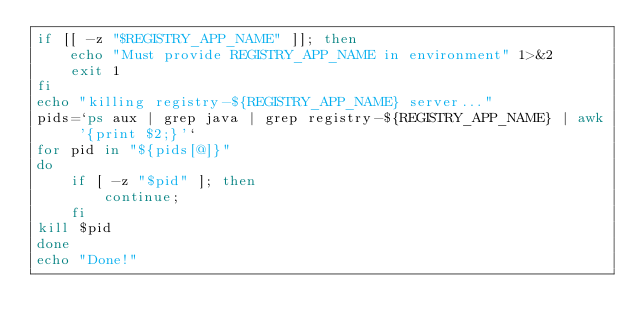Convert code to text. <code><loc_0><loc_0><loc_500><loc_500><_Bash_>if [[ -z "$REGISTRY_APP_NAME" ]]; then
    echo "Must provide REGISTRY_APP_NAME in environment" 1>&2
    exit 1
fi
echo "killing registry-${REGISTRY_APP_NAME} server..."
pids=`ps aux | grep java | grep registry-${REGISTRY_APP_NAME} | awk '{print $2;}'`
for pid in "${pids[@]}"
do
    if [ -z "$pid" ]; then
        continue;
    fi
kill $pid
done
echo "Done!"</code> 